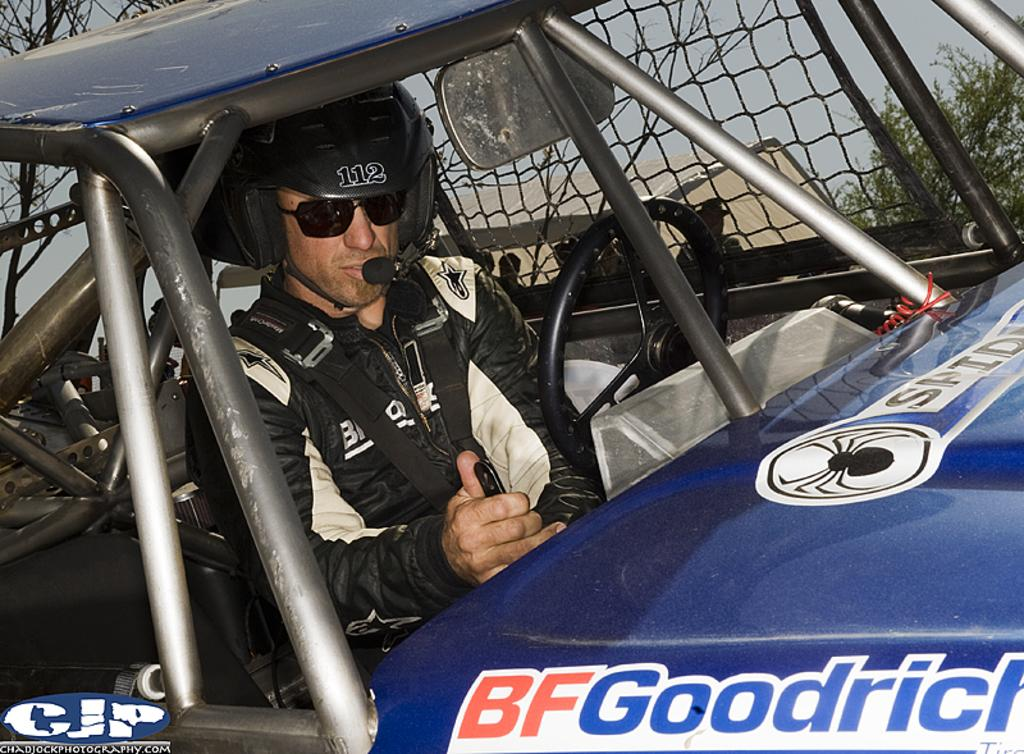What is the main subject of the image? There is a person in a vehicle in the image. What can be seen on the right side of the image? There are leaves visible on the right side of the image. What is located on the left side of the image? There is a tree on the left side of the image. Can you describe the watermark in the image? There is a watermark in the bottom left corner of the image. Reasoning: Let'g: Let's think step by step in order to produce the conversation. We start by identifying the main subject of the image, which is the person in a vehicle. Then, we describe the surrounding environment, including the leaves on the right side and the tree on the left side. Finally, we acknowledge the presence of the watermark in the image, which is a common feature in digital images. Absurd Question/Answer: What type of stamp can be seen on the paper in the image? There is no paper or stamp present in the image. 